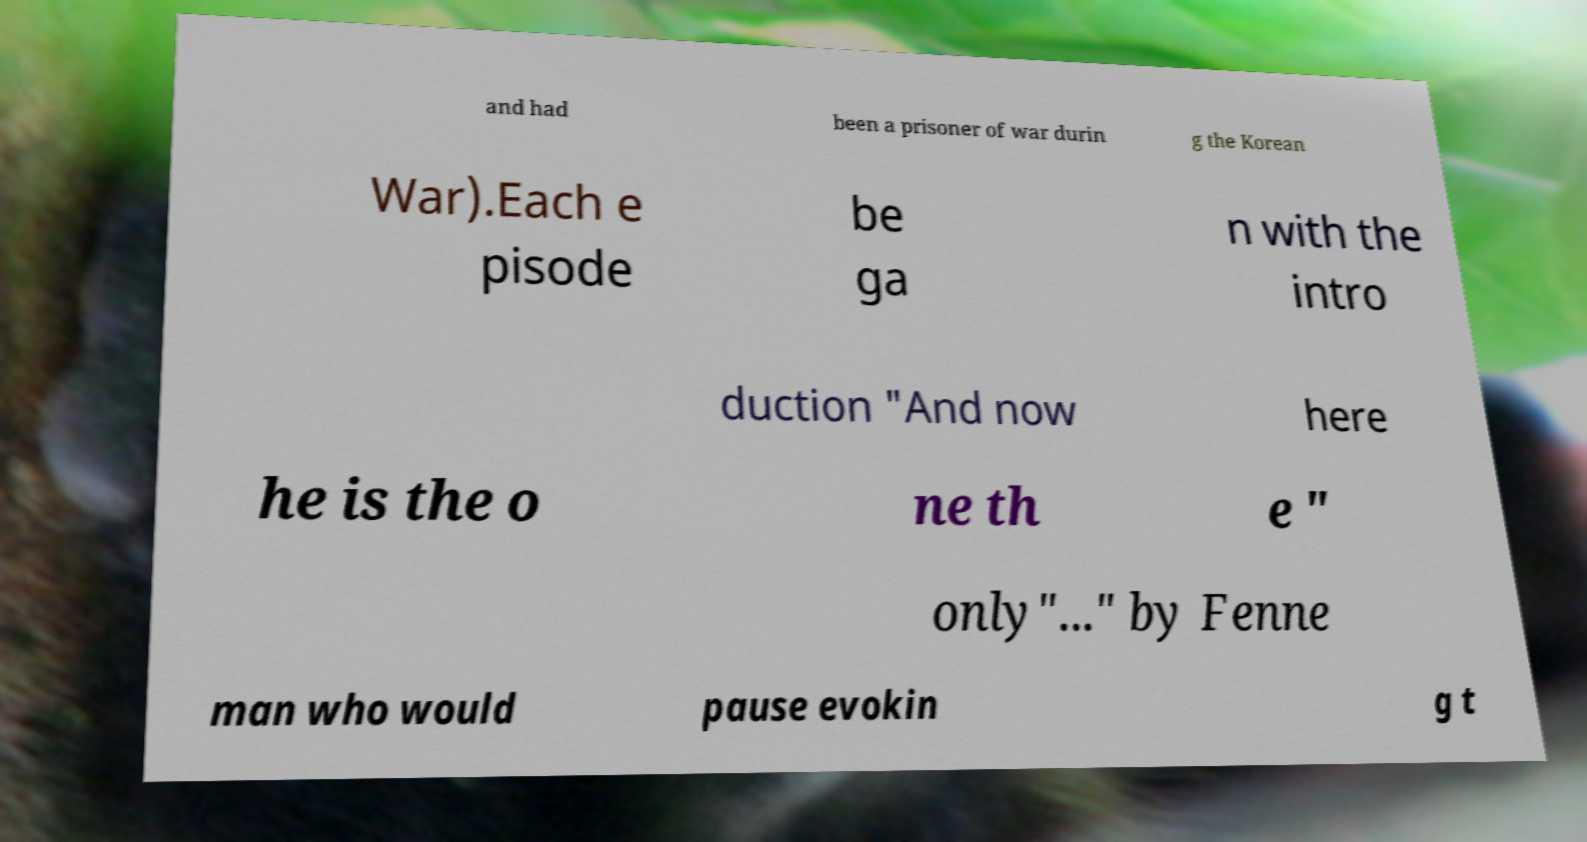Please identify and transcribe the text found in this image. and had been a prisoner of war durin g the Korean War).Each e pisode be ga n with the intro duction "And now here he is the o ne th e " only"..." by Fenne man who would pause evokin g t 